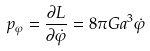Convert formula to latex. <formula><loc_0><loc_0><loc_500><loc_500>p _ { \varphi } = \frac { \partial L } { \partial \dot { \varphi } } = 8 \pi G a ^ { 3 } \dot { \varphi }</formula> 